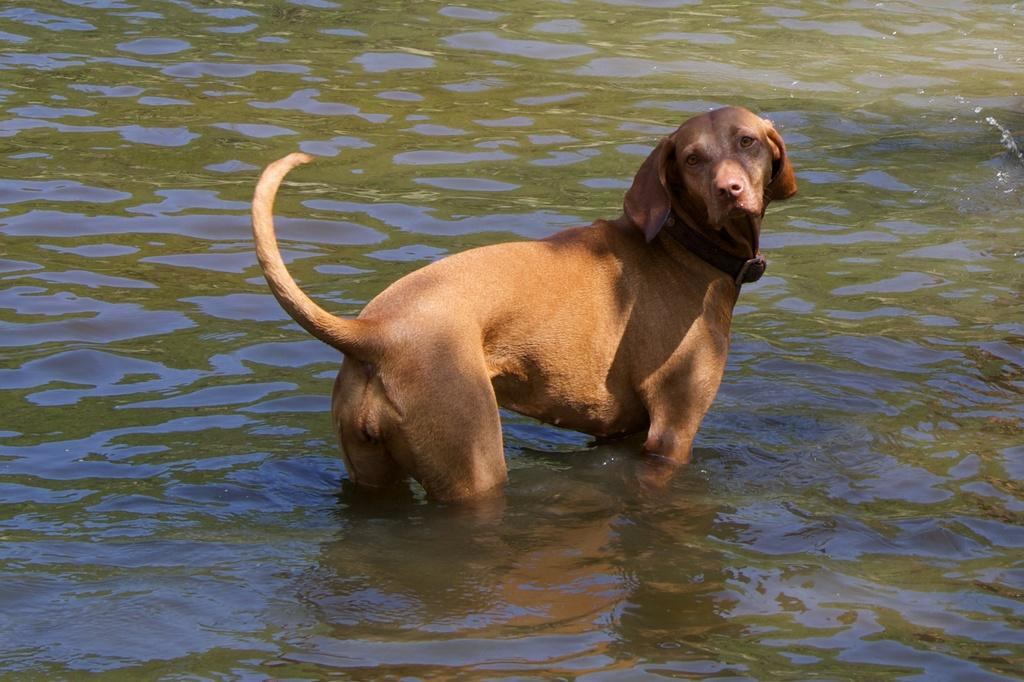What type of animal is in the image? There is a light brown color dog in the image. Where is the dog located in the image? The dog is standing in the water. What else can be seen in the image besides the dog? There is water visible in the image. Is there any other effect created by the dog's presence in the water? Yes, there is a reflection of the dog on the water. What type of card is the dog holding in the image? There is no card present in the image; the dog is standing in the water. What is the dog's name in the image? The provided facts do not mention the dog's name, so we cannot determine it from the image. 